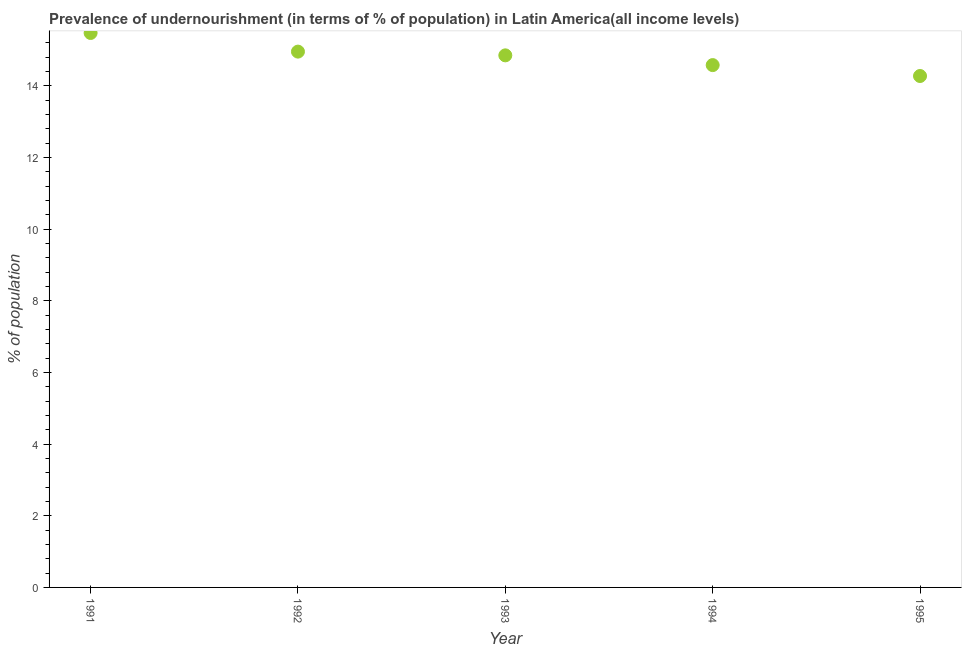What is the percentage of undernourished population in 1992?
Your response must be concise. 14.96. Across all years, what is the maximum percentage of undernourished population?
Offer a very short reply. 15.48. Across all years, what is the minimum percentage of undernourished population?
Offer a terse response. 14.27. In which year was the percentage of undernourished population maximum?
Offer a very short reply. 1991. What is the sum of the percentage of undernourished population?
Ensure brevity in your answer.  74.14. What is the difference between the percentage of undernourished population in 1994 and 1995?
Make the answer very short. 0.3. What is the average percentage of undernourished population per year?
Provide a succinct answer. 14.83. What is the median percentage of undernourished population?
Your response must be concise. 14.85. What is the ratio of the percentage of undernourished population in 1994 to that in 1995?
Your response must be concise. 1.02. Is the percentage of undernourished population in 1991 less than that in 1992?
Offer a very short reply. No. What is the difference between the highest and the second highest percentage of undernourished population?
Your response must be concise. 0.52. Is the sum of the percentage of undernourished population in 1993 and 1995 greater than the maximum percentage of undernourished population across all years?
Your answer should be very brief. Yes. What is the difference between the highest and the lowest percentage of undernourished population?
Your answer should be very brief. 1.2. In how many years, is the percentage of undernourished population greater than the average percentage of undernourished population taken over all years?
Keep it short and to the point. 3. Does the percentage of undernourished population monotonically increase over the years?
Provide a succinct answer. No. How many dotlines are there?
Keep it short and to the point. 1. How many years are there in the graph?
Provide a short and direct response. 5. What is the difference between two consecutive major ticks on the Y-axis?
Your response must be concise. 2. Are the values on the major ticks of Y-axis written in scientific E-notation?
Keep it short and to the point. No. Does the graph contain grids?
Your response must be concise. No. What is the title of the graph?
Offer a terse response. Prevalence of undernourishment (in terms of % of population) in Latin America(all income levels). What is the label or title of the Y-axis?
Your answer should be very brief. % of population. What is the % of population in 1991?
Offer a very short reply. 15.48. What is the % of population in 1992?
Offer a very short reply. 14.96. What is the % of population in 1993?
Ensure brevity in your answer.  14.85. What is the % of population in 1994?
Provide a succinct answer. 14.58. What is the % of population in 1995?
Ensure brevity in your answer.  14.27. What is the difference between the % of population in 1991 and 1992?
Give a very brief answer. 0.52. What is the difference between the % of population in 1991 and 1993?
Keep it short and to the point. 0.62. What is the difference between the % of population in 1991 and 1994?
Keep it short and to the point. 0.9. What is the difference between the % of population in 1991 and 1995?
Your answer should be very brief. 1.2. What is the difference between the % of population in 1992 and 1993?
Your answer should be very brief. 0.1. What is the difference between the % of population in 1992 and 1994?
Make the answer very short. 0.38. What is the difference between the % of population in 1992 and 1995?
Provide a short and direct response. 0.68. What is the difference between the % of population in 1993 and 1994?
Give a very brief answer. 0.27. What is the difference between the % of population in 1993 and 1995?
Offer a terse response. 0.58. What is the difference between the % of population in 1994 and 1995?
Make the answer very short. 0.3. What is the ratio of the % of population in 1991 to that in 1992?
Provide a succinct answer. 1.03. What is the ratio of the % of population in 1991 to that in 1993?
Your response must be concise. 1.04. What is the ratio of the % of population in 1991 to that in 1994?
Offer a very short reply. 1.06. What is the ratio of the % of population in 1991 to that in 1995?
Your answer should be very brief. 1.08. What is the ratio of the % of population in 1992 to that in 1993?
Your answer should be very brief. 1.01. What is the ratio of the % of population in 1992 to that in 1994?
Offer a terse response. 1.03. What is the ratio of the % of population in 1992 to that in 1995?
Give a very brief answer. 1.05. 